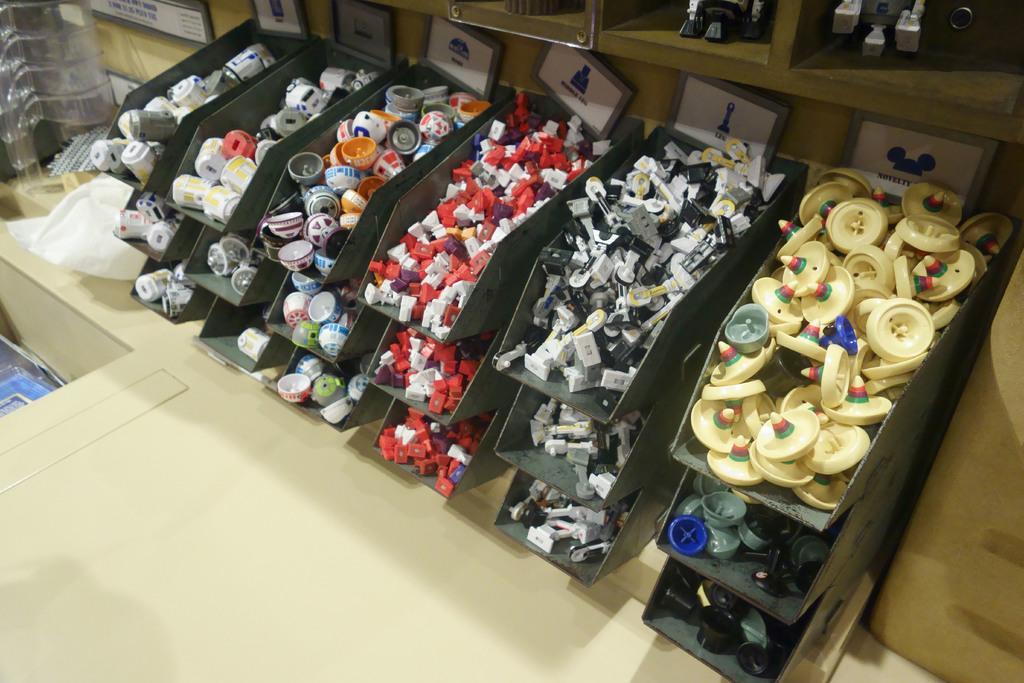Describe this image in one or two sentences. In this image we can see some things placed in a shelves. 